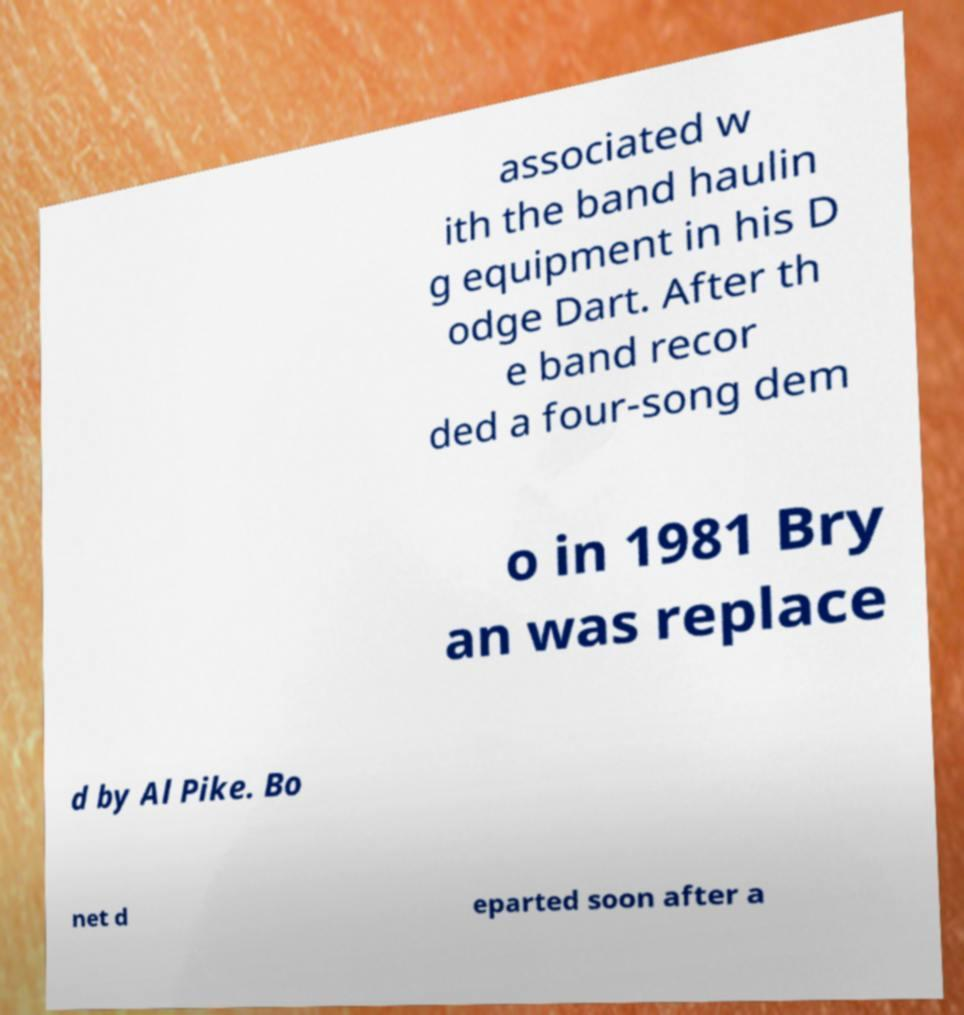Please read and relay the text visible in this image. What does it say? associated w ith the band haulin g equipment in his D odge Dart. After th e band recor ded a four-song dem o in 1981 Bry an was replace d by Al Pike. Bo net d eparted soon after a 